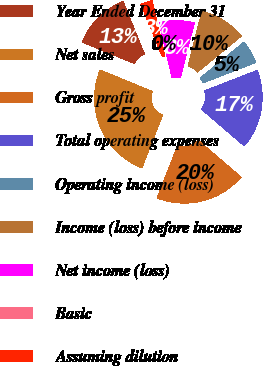Convert chart. <chart><loc_0><loc_0><loc_500><loc_500><pie_chart><fcel>Year Ended December 31<fcel>Net sales<fcel>Gross profit<fcel>Total operating expenses<fcel>Operating income (loss)<fcel>Income (loss) before income<fcel>Net income (loss)<fcel>Basic<fcel>Assuming dilution<nl><fcel>12.63%<fcel>25.27%<fcel>19.68%<fcel>17.15%<fcel>5.05%<fcel>10.11%<fcel>7.58%<fcel>0.0%<fcel>2.53%<nl></chart> 